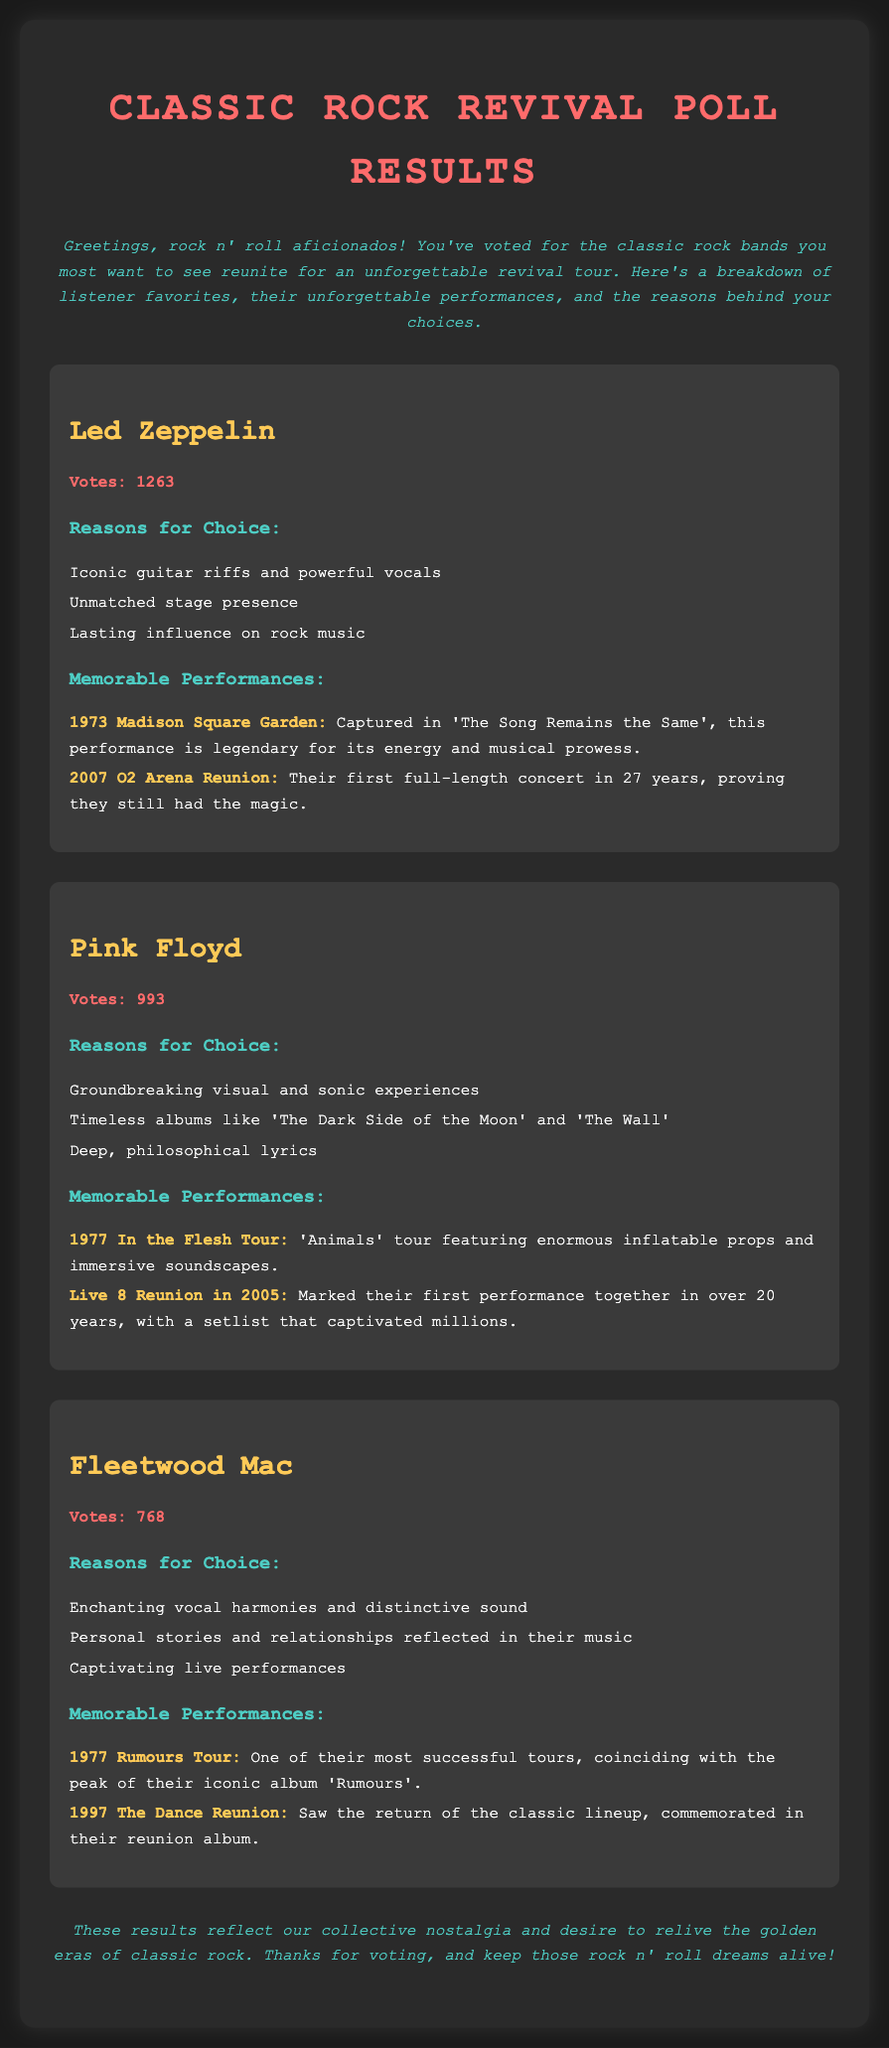What is the title of the document? The title of the document is presented in the main heading.
Answer: Classic Rock Revival Poll Results How many votes did Pink Floyd receive? The votes for each band are displayed directly beneath their names.
Answer: 993 What is one reason listeners chose Fleetwood Mac? The reasons for each band's choice are listed in a section under their names.
Answer: Enchanting vocal harmonies and distinctive sound Which band had a memorable performance in 1997? The performances are listed along with their years under each band.
Answer: Fleetwood Mac What year did Led Zeppelin perform at the Madison Square Garden? The years of memorable performances are specified near each performance title.
Answer: 1973 Name one timeless album by Pink Floyd. The document mentions albums that contributed to the band's popularity.
Answer: The Dark Side of the Moon How many votes did Led Zeppelin receive? The total votes for Led Zeppelin are clearly stated in the document.
Answer: 1263 What was one notable feature of the 1977 In the Flesh Tour? This information can be inferred from the description of the performances listed for Pink Floyd.
Answer: Enormous inflatable props and immersive soundscapes 